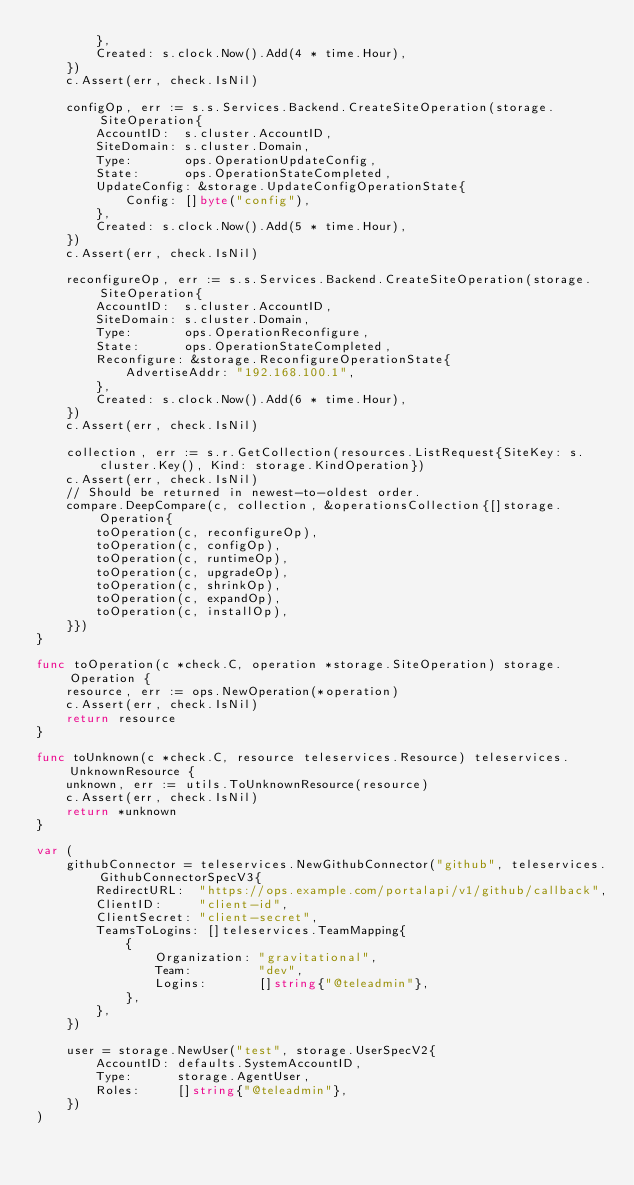<code> <loc_0><loc_0><loc_500><loc_500><_Go_>		},
		Created: s.clock.Now().Add(4 * time.Hour),
	})
	c.Assert(err, check.IsNil)

	configOp, err := s.s.Services.Backend.CreateSiteOperation(storage.SiteOperation{
		AccountID:  s.cluster.AccountID,
		SiteDomain: s.cluster.Domain,
		Type:       ops.OperationUpdateConfig,
		State:      ops.OperationStateCompleted,
		UpdateConfig: &storage.UpdateConfigOperationState{
			Config: []byte("config"),
		},
		Created: s.clock.Now().Add(5 * time.Hour),
	})
	c.Assert(err, check.IsNil)

	reconfigureOp, err := s.s.Services.Backend.CreateSiteOperation(storage.SiteOperation{
		AccountID:  s.cluster.AccountID,
		SiteDomain: s.cluster.Domain,
		Type:       ops.OperationReconfigure,
		State:      ops.OperationStateCompleted,
		Reconfigure: &storage.ReconfigureOperationState{
			AdvertiseAddr: "192.168.100.1",
		},
		Created: s.clock.Now().Add(6 * time.Hour),
	})
	c.Assert(err, check.IsNil)

	collection, err := s.r.GetCollection(resources.ListRequest{SiteKey: s.cluster.Key(), Kind: storage.KindOperation})
	c.Assert(err, check.IsNil)
	// Should be returned in newest-to-oldest order.
	compare.DeepCompare(c, collection, &operationsCollection{[]storage.Operation{
		toOperation(c, reconfigureOp),
		toOperation(c, configOp),
		toOperation(c, runtimeOp),
		toOperation(c, upgradeOp),
		toOperation(c, shrinkOp),
		toOperation(c, expandOp),
		toOperation(c, installOp),
	}})
}

func toOperation(c *check.C, operation *storage.SiteOperation) storage.Operation {
	resource, err := ops.NewOperation(*operation)
	c.Assert(err, check.IsNil)
	return resource
}

func toUnknown(c *check.C, resource teleservices.Resource) teleservices.UnknownResource {
	unknown, err := utils.ToUnknownResource(resource)
	c.Assert(err, check.IsNil)
	return *unknown
}

var (
	githubConnector = teleservices.NewGithubConnector("github", teleservices.GithubConnectorSpecV3{
		RedirectURL:  "https://ops.example.com/portalapi/v1/github/callback",
		ClientID:     "client-id",
		ClientSecret: "client-secret",
		TeamsToLogins: []teleservices.TeamMapping{
			{
				Organization: "gravitational",
				Team:         "dev",
				Logins:       []string{"@teleadmin"},
			},
		},
	})

	user = storage.NewUser("test", storage.UserSpecV2{
		AccountID: defaults.SystemAccountID,
		Type:      storage.AgentUser,
		Roles:     []string{"@teleadmin"},
	})
)
</code> 